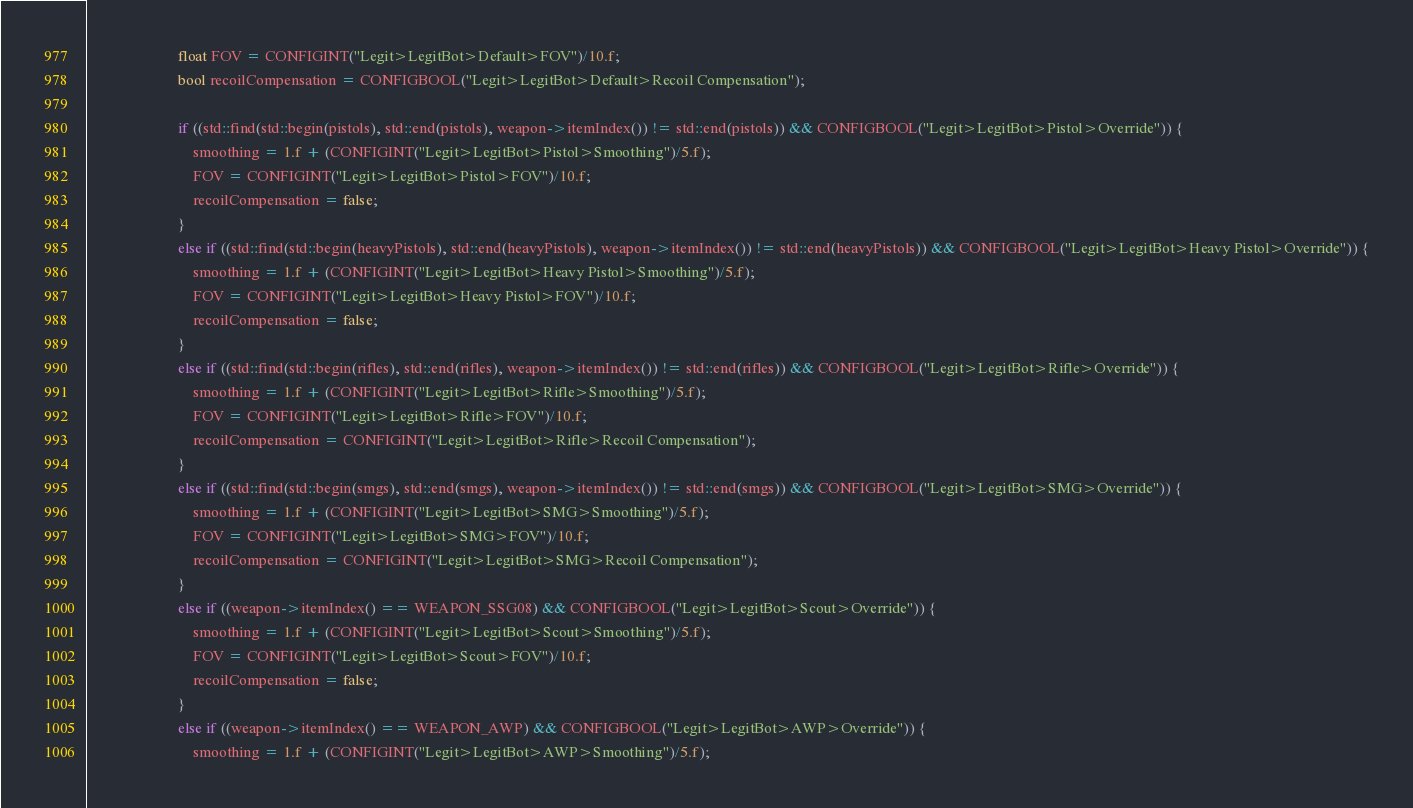<code> <loc_0><loc_0><loc_500><loc_500><_C++_>                        float FOV = CONFIGINT("Legit>LegitBot>Default>FOV")/10.f;
                        bool recoilCompensation = CONFIGBOOL("Legit>LegitBot>Default>Recoil Compensation");

                        if ((std::find(std::begin(pistols), std::end(pistols), weapon->itemIndex()) != std::end(pistols)) && CONFIGBOOL("Legit>LegitBot>Pistol>Override")) {
                            smoothing = 1.f + (CONFIGINT("Legit>LegitBot>Pistol>Smoothing")/5.f);
                            FOV = CONFIGINT("Legit>LegitBot>Pistol>FOV")/10.f;
                            recoilCompensation = false;
                        }
                        else if ((std::find(std::begin(heavyPistols), std::end(heavyPistols), weapon->itemIndex()) != std::end(heavyPistols)) && CONFIGBOOL("Legit>LegitBot>Heavy Pistol>Override")) {
                            smoothing = 1.f + (CONFIGINT("Legit>LegitBot>Heavy Pistol>Smoothing")/5.f);
                            FOV = CONFIGINT("Legit>LegitBot>Heavy Pistol>FOV")/10.f;
                            recoilCompensation = false;
                        }
                        else if ((std::find(std::begin(rifles), std::end(rifles), weapon->itemIndex()) != std::end(rifles)) && CONFIGBOOL("Legit>LegitBot>Rifle>Override")) {
                            smoothing = 1.f + (CONFIGINT("Legit>LegitBot>Rifle>Smoothing")/5.f);
                            FOV = CONFIGINT("Legit>LegitBot>Rifle>FOV")/10.f;
                            recoilCompensation = CONFIGINT("Legit>LegitBot>Rifle>Recoil Compensation");
                        }
                        else if ((std::find(std::begin(smgs), std::end(smgs), weapon->itemIndex()) != std::end(smgs)) && CONFIGBOOL("Legit>LegitBot>SMG>Override")) {
                            smoothing = 1.f + (CONFIGINT("Legit>LegitBot>SMG>Smoothing")/5.f);
                            FOV = CONFIGINT("Legit>LegitBot>SMG>FOV")/10.f;
                            recoilCompensation = CONFIGINT("Legit>LegitBot>SMG>Recoil Compensation");
                        }
                        else if ((weapon->itemIndex() == WEAPON_SSG08) && CONFIGBOOL("Legit>LegitBot>Scout>Override")) {
                            smoothing = 1.f + (CONFIGINT("Legit>LegitBot>Scout>Smoothing")/5.f);
                            FOV = CONFIGINT("Legit>LegitBot>Scout>FOV")/10.f;
                            recoilCompensation = false;
                        }
                        else if ((weapon->itemIndex() == WEAPON_AWP) && CONFIGBOOL("Legit>LegitBot>AWP>Override")) {
                            smoothing = 1.f + (CONFIGINT("Legit>LegitBot>AWP>Smoothing")/5.f);</code> 